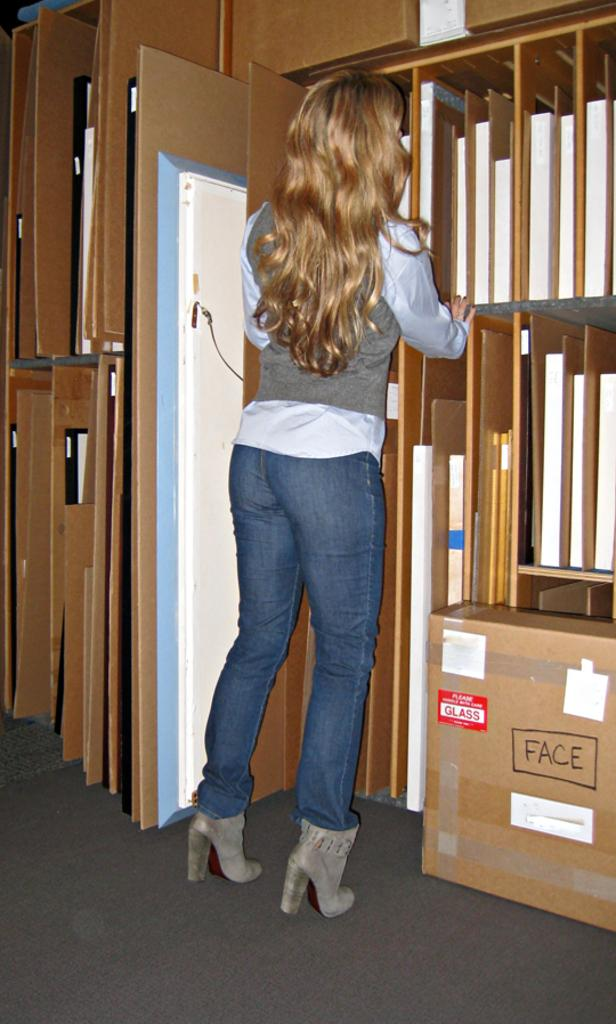<image>
Describe the image concisely. A woman with blond hair is searching a shelf above a box marked with a red sticker that says Glass. 